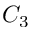<formula> <loc_0><loc_0><loc_500><loc_500>C _ { 3 }</formula> 